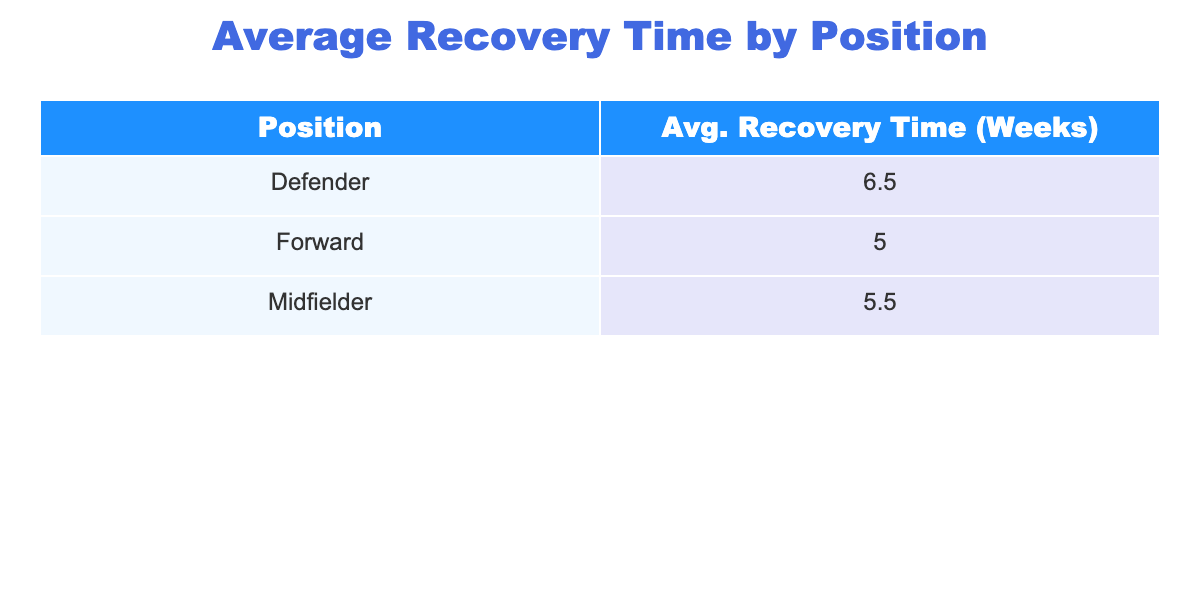What is the average recovery time for midfielders? The table shows that the average recovery time for midfielders is derived from Kevin De Bruyne (6 weeks) and N'Golo Kanté (5 weeks). Thus, the average is (6 + 5) / 2 = 5.5 weeks.
Answer: 5.5 weeks Which position has the shortest average recovery time? By examining the average recovery times for each position in the table, it’s evident that forwards have a recovery time of 5 weeks (3 weeks, 4 weeks, 5 weeks, 8 weeks), while defenders have 6.5 weeks [(9 + 4) / 2] on average, thus forwards have the shortest average time.
Answer: Forwards Is there a player who experienced both a hamstring injury and knee injury? The table lists only one player, Marcus Rashford, who suffered a hamstring strain. No players in the table are listed with a knee injury. Thus, there is no player who experienced both.
Answer: No What is the total incidence of injuries recorded for forwards? The total incidence for forwards can be summed from all forward positions: Marcus Rashford (5), Harry Kane (2), Raheem Sterling (6), Gareth Bale (1), and Sadio Mané (2). This totals 5 + 2 + 6 + 1 + 2 = 16.
Answer: 16 Which player took the longest to recover and what was their recovery time? Reviewing the table, Virgil van Dijk suffered an ACL Tear and had the longest recovery time of 9 weeks. This is confirmed by checking the recovery times of all players, confirming he had the highest.
Answer: Virgil van Dijk, 9 weeks 